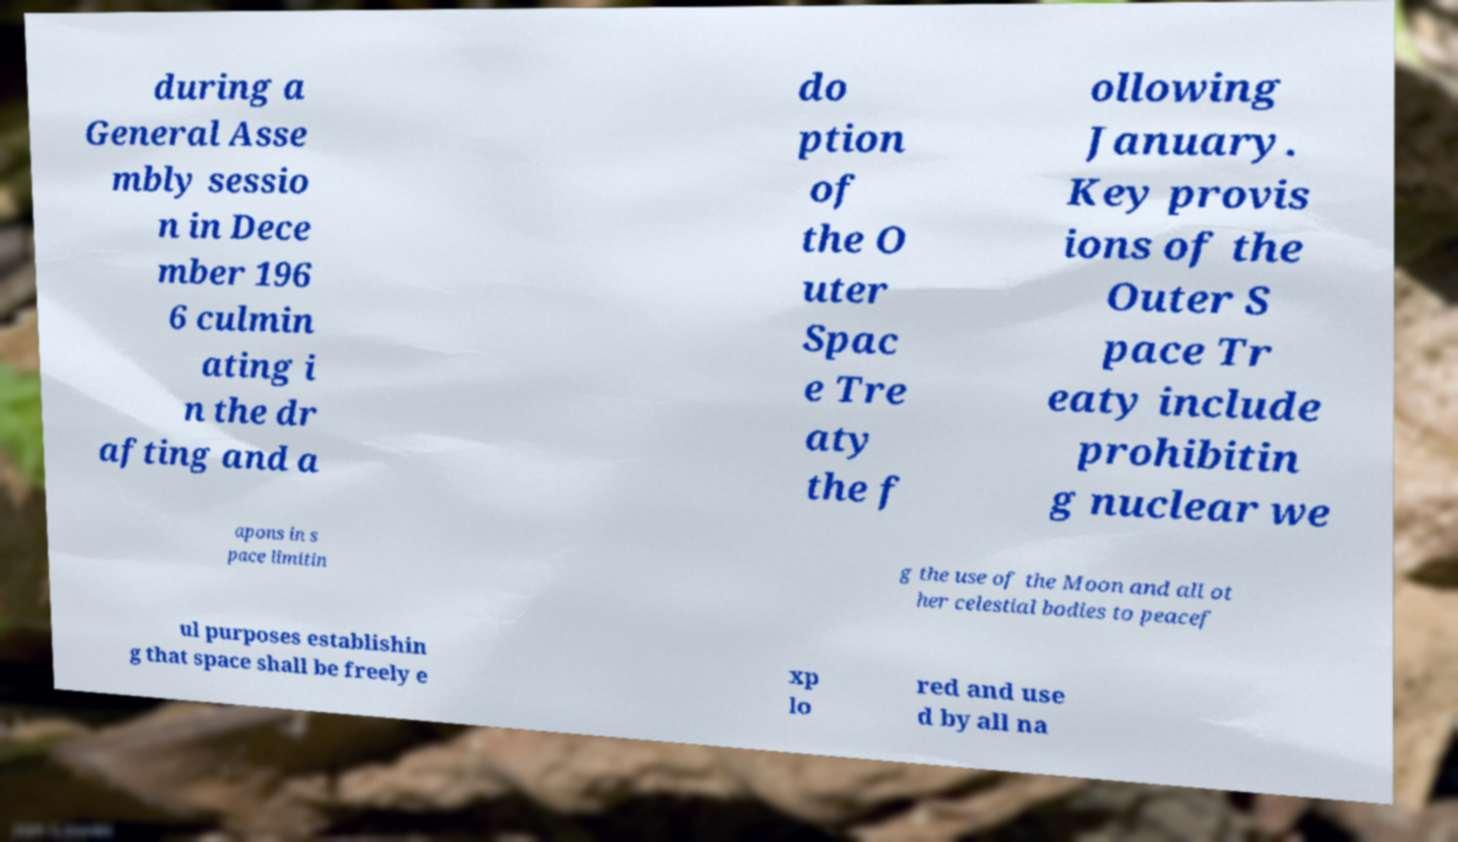Could you extract and type out the text from this image? during a General Asse mbly sessio n in Dece mber 196 6 culmin ating i n the dr afting and a do ption of the O uter Spac e Tre aty the f ollowing January. Key provis ions of the Outer S pace Tr eaty include prohibitin g nuclear we apons in s pace limitin g the use of the Moon and all ot her celestial bodies to peacef ul purposes establishin g that space shall be freely e xp lo red and use d by all na 